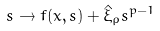<formula> <loc_0><loc_0><loc_500><loc_500>s \to f ( x , s ) + \hat { \xi } _ { \rho } s ^ { p - 1 }</formula> 